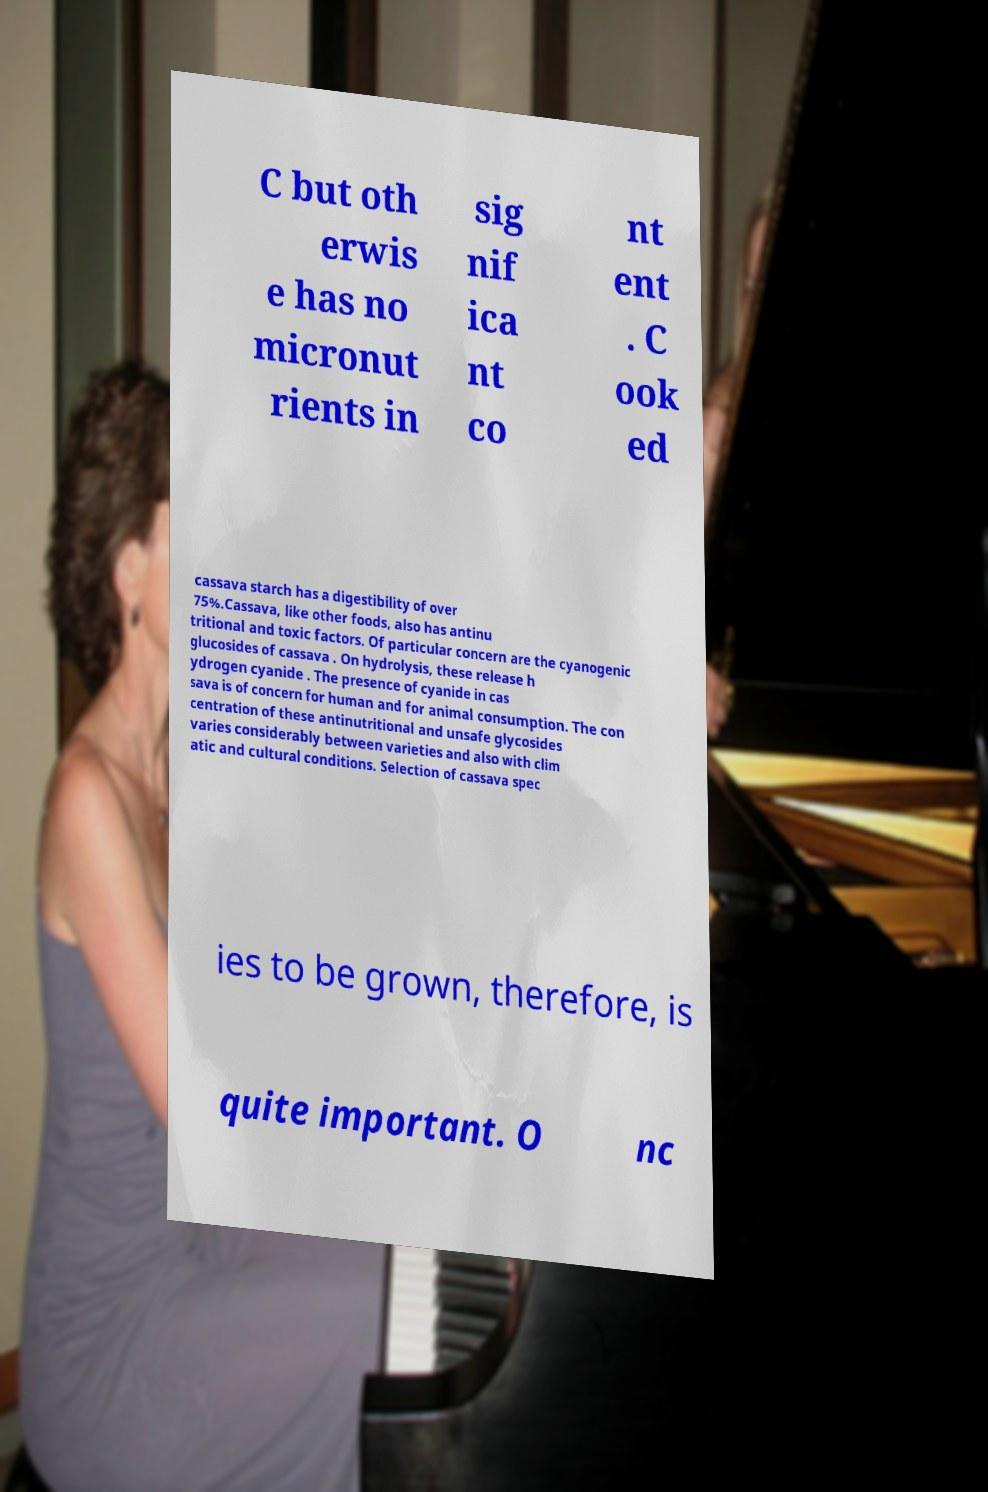Could you assist in decoding the text presented in this image and type it out clearly? C but oth erwis e has no micronut rients in sig nif ica nt co nt ent . C ook ed cassava starch has a digestibility of over 75%.Cassava, like other foods, also has antinu tritional and toxic factors. Of particular concern are the cyanogenic glucosides of cassava . On hydrolysis, these release h ydrogen cyanide . The presence of cyanide in cas sava is of concern for human and for animal consumption. The con centration of these antinutritional and unsafe glycosides varies considerably between varieties and also with clim atic and cultural conditions. Selection of cassava spec ies to be grown, therefore, is quite important. O nc 